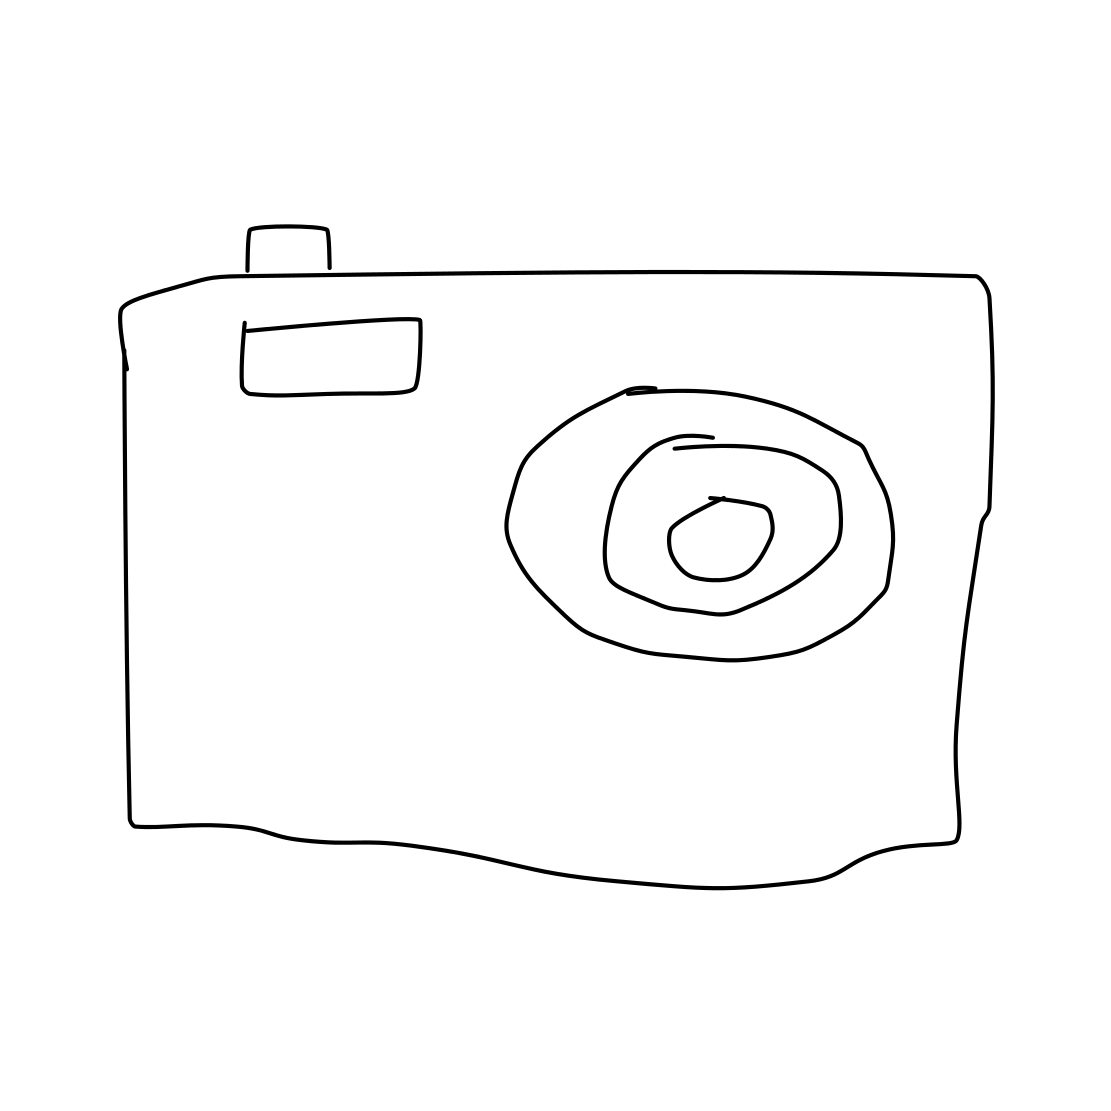In the scene, is a hedgehog in it? After carefully inspecting the image, I can confirm that there is no hedgehog present. The image depicts a simple line drawing of a camera, with no other animals or objects in sight. 